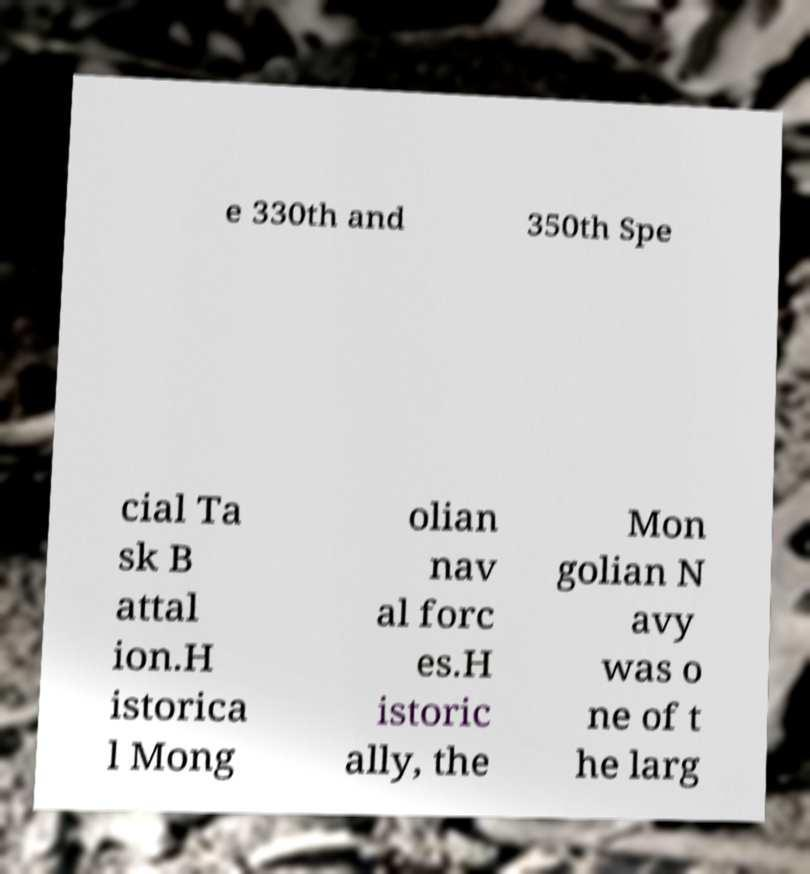I need the written content from this picture converted into text. Can you do that? e 330th and 350th Spe cial Ta sk B attal ion.H istorica l Mong olian nav al forc es.H istoric ally, the Mon golian N avy was o ne of t he larg 